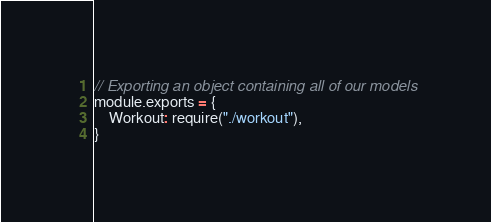Convert code to text. <code><loc_0><loc_0><loc_500><loc_500><_JavaScript_>// Exporting an object containing all of our models
module.exports = {
    Workout: require("./workout"),
}</code> 